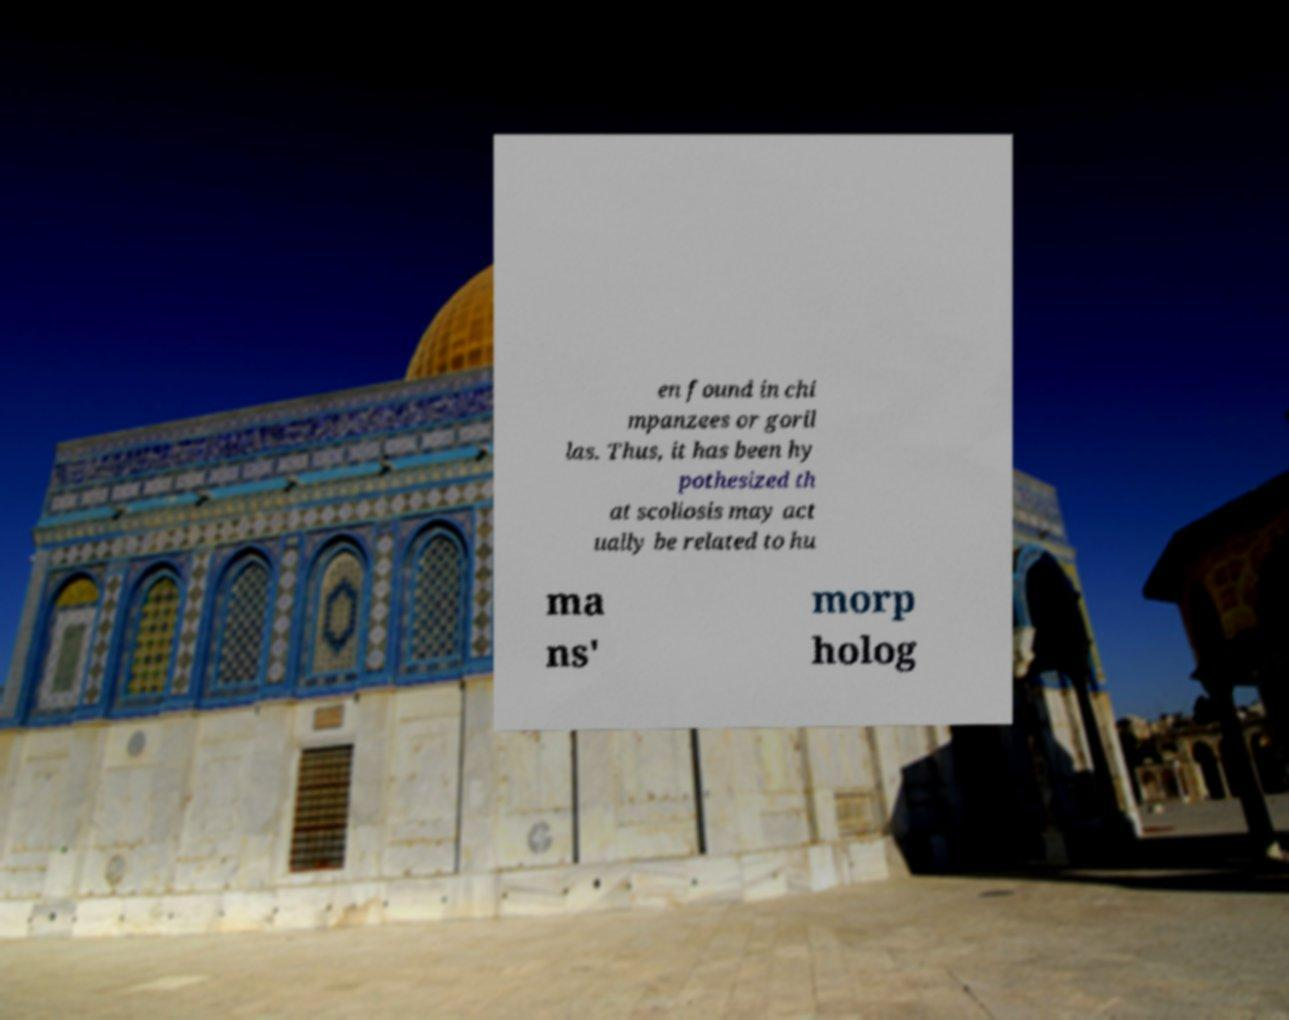Please identify and transcribe the text found in this image. en found in chi mpanzees or goril las. Thus, it has been hy pothesized th at scoliosis may act ually be related to hu ma ns' morp holog 